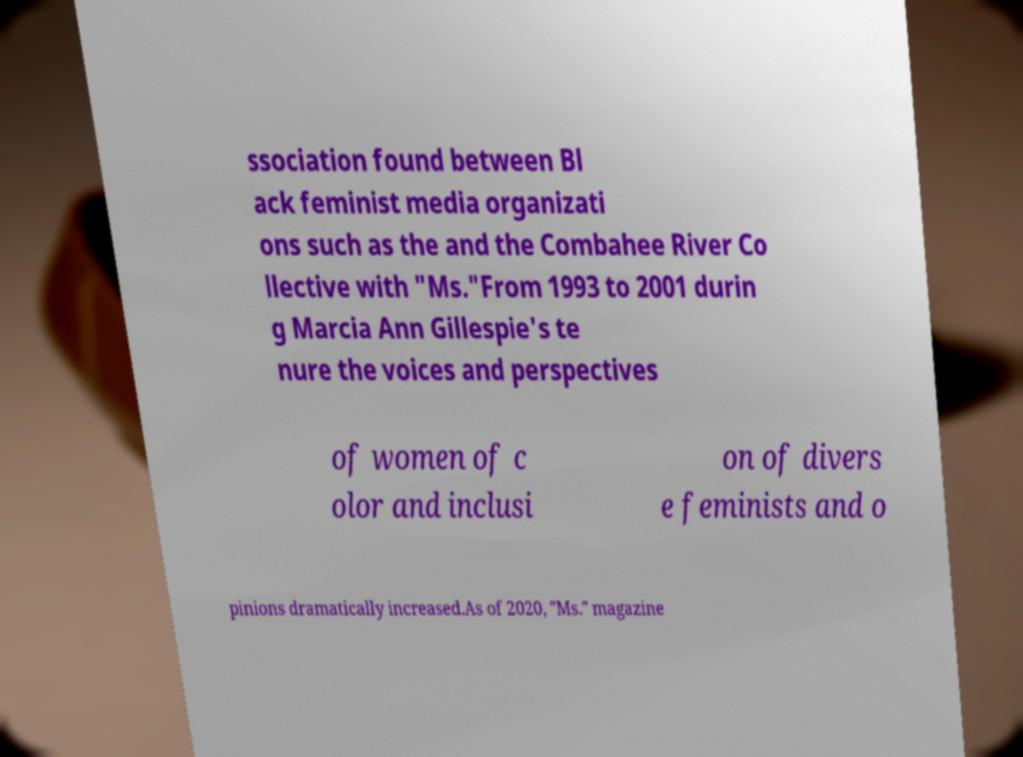Please identify and transcribe the text found in this image. ssociation found between Bl ack feminist media organizati ons such as the and the Combahee River Co llective with "Ms."From 1993 to 2001 durin g Marcia Ann Gillespie's te nure the voices and perspectives of women of c olor and inclusi on of divers e feminists and o pinions dramatically increased.As of 2020, "Ms." magazine 